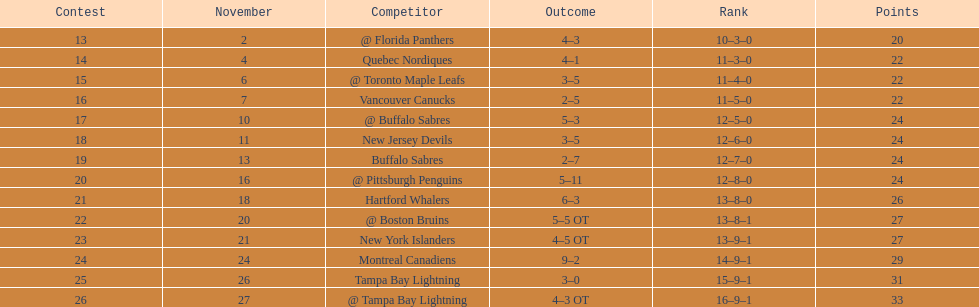Who are all of the teams? @ Florida Panthers, Quebec Nordiques, @ Toronto Maple Leafs, Vancouver Canucks, @ Buffalo Sabres, New Jersey Devils, Buffalo Sabres, @ Pittsburgh Penguins, Hartford Whalers, @ Boston Bruins, New York Islanders, Montreal Canadiens, Tampa Bay Lightning. What games finished in overtime? 22, 23, 26. In game number 23, who did they face? New York Islanders. 